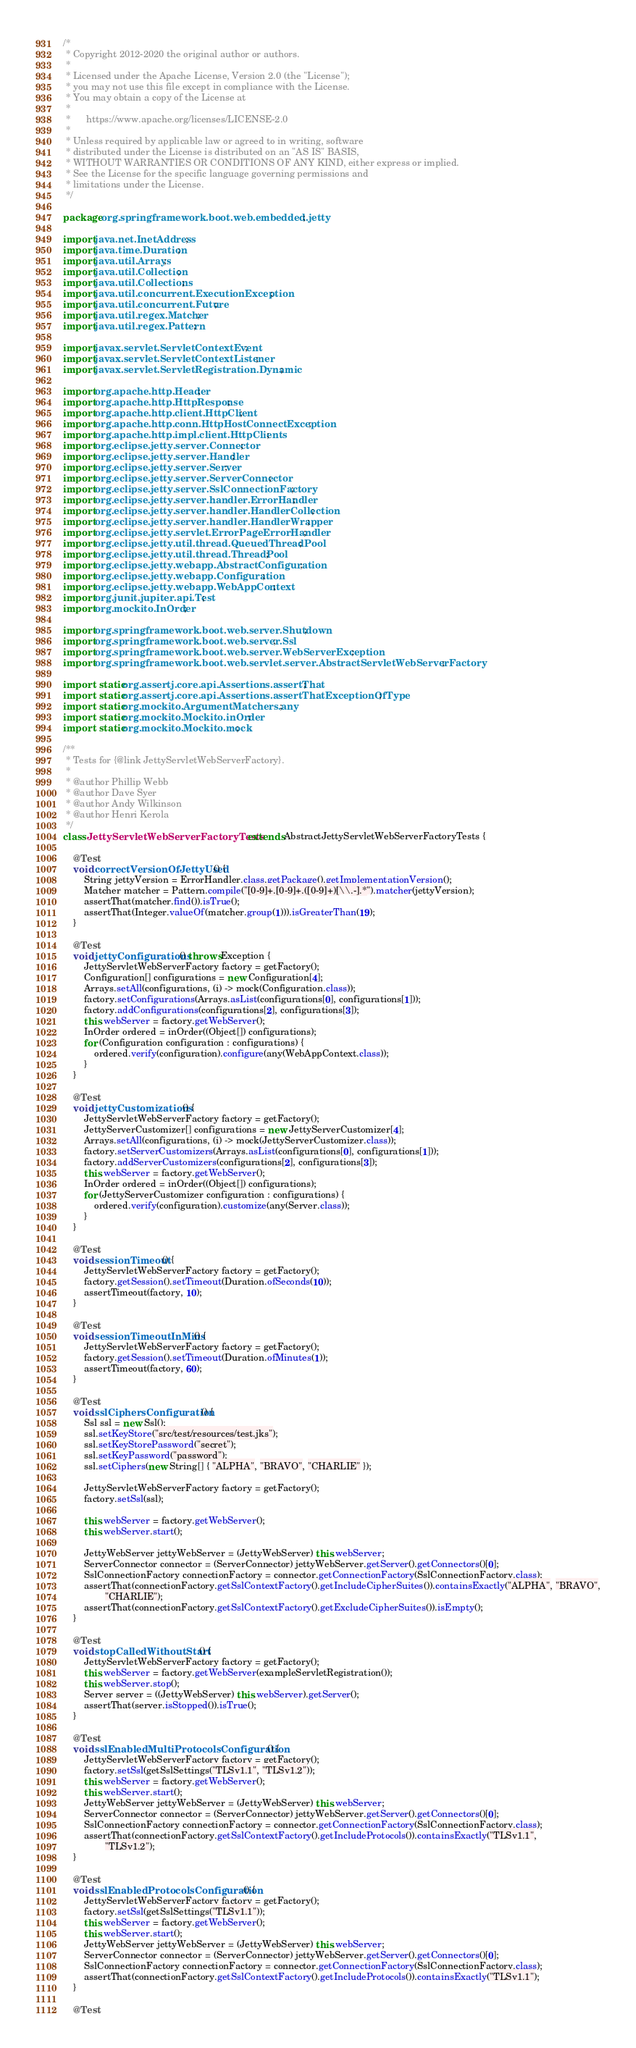<code> <loc_0><loc_0><loc_500><loc_500><_Java_>/*
 * Copyright 2012-2020 the original author or authors.
 *
 * Licensed under the Apache License, Version 2.0 (the "License");
 * you may not use this file except in compliance with the License.
 * You may obtain a copy of the License at
 *
 *      https://www.apache.org/licenses/LICENSE-2.0
 *
 * Unless required by applicable law or agreed to in writing, software
 * distributed under the License is distributed on an "AS IS" BASIS,
 * WITHOUT WARRANTIES OR CONDITIONS OF ANY KIND, either express or implied.
 * See the License for the specific language governing permissions and
 * limitations under the License.
 */

package org.springframework.boot.web.embedded.jetty;

import java.net.InetAddress;
import java.time.Duration;
import java.util.Arrays;
import java.util.Collection;
import java.util.Collections;
import java.util.concurrent.ExecutionException;
import java.util.concurrent.Future;
import java.util.regex.Matcher;
import java.util.regex.Pattern;

import javax.servlet.ServletContextEvent;
import javax.servlet.ServletContextListener;
import javax.servlet.ServletRegistration.Dynamic;

import org.apache.http.Header;
import org.apache.http.HttpResponse;
import org.apache.http.client.HttpClient;
import org.apache.http.conn.HttpHostConnectException;
import org.apache.http.impl.client.HttpClients;
import org.eclipse.jetty.server.Connector;
import org.eclipse.jetty.server.Handler;
import org.eclipse.jetty.server.Server;
import org.eclipse.jetty.server.ServerConnector;
import org.eclipse.jetty.server.SslConnectionFactory;
import org.eclipse.jetty.server.handler.ErrorHandler;
import org.eclipse.jetty.server.handler.HandlerCollection;
import org.eclipse.jetty.server.handler.HandlerWrapper;
import org.eclipse.jetty.servlet.ErrorPageErrorHandler;
import org.eclipse.jetty.util.thread.QueuedThreadPool;
import org.eclipse.jetty.util.thread.ThreadPool;
import org.eclipse.jetty.webapp.AbstractConfiguration;
import org.eclipse.jetty.webapp.Configuration;
import org.eclipse.jetty.webapp.WebAppContext;
import org.junit.jupiter.api.Test;
import org.mockito.InOrder;

import org.springframework.boot.web.server.Shutdown;
import org.springframework.boot.web.server.Ssl;
import org.springframework.boot.web.server.WebServerException;
import org.springframework.boot.web.servlet.server.AbstractServletWebServerFactory;

import static org.assertj.core.api.Assertions.assertThat;
import static org.assertj.core.api.Assertions.assertThatExceptionOfType;
import static org.mockito.ArgumentMatchers.any;
import static org.mockito.Mockito.inOrder;
import static org.mockito.Mockito.mock;

/**
 * Tests for {@link JettyServletWebServerFactory}.
 *
 * @author Phillip Webb
 * @author Dave Syer
 * @author Andy Wilkinson
 * @author Henri Kerola
 */
class JettyServletWebServerFactoryTests extends AbstractJettyServletWebServerFactoryTests {

	@Test
	void correctVersionOfJettyUsed() {
		String jettyVersion = ErrorHandler.class.getPackage().getImplementationVersion();
		Matcher matcher = Pattern.compile("[0-9]+.[0-9]+.([0-9]+)[\\.-].*").matcher(jettyVersion);
		assertThat(matcher.find()).isTrue();
		assertThat(Integer.valueOf(matcher.group(1))).isGreaterThan(19);
	}

	@Test
	void jettyConfigurations() throws Exception {
		JettyServletWebServerFactory factory = getFactory();
		Configuration[] configurations = new Configuration[4];
		Arrays.setAll(configurations, (i) -> mock(Configuration.class));
		factory.setConfigurations(Arrays.asList(configurations[0], configurations[1]));
		factory.addConfigurations(configurations[2], configurations[3]);
		this.webServer = factory.getWebServer();
		InOrder ordered = inOrder((Object[]) configurations);
		for (Configuration configuration : configurations) {
			ordered.verify(configuration).configure(any(WebAppContext.class));
		}
	}

	@Test
	void jettyCustomizations() {
		JettyServletWebServerFactory factory = getFactory();
		JettyServerCustomizer[] configurations = new JettyServerCustomizer[4];
		Arrays.setAll(configurations, (i) -> mock(JettyServerCustomizer.class));
		factory.setServerCustomizers(Arrays.asList(configurations[0], configurations[1]));
		factory.addServerCustomizers(configurations[2], configurations[3]);
		this.webServer = factory.getWebServer();
		InOrder ordered = inOrder((Object[]) configurations);
		for (JettyServerCustomizer configuration : configurations) {
			ordered.verify(configuration).customize(any(Server.class));
		}
	}

	@Test
	void sessionTimeout() {
		JettyServletWebServerFactory factory = getFactory();
		factory.getSession().setTimeout(Duration.ofSeconds(10));
		assertTimeout(factory, 10);
	}

	@Test
	void sessionTimeoutInMins() {
		JettyServletWebServerFactory factory = getFactory();
		factory.getSession().setTimeout(Duration.ofMinutes(1));
		assertTimeout(factory, 60);
	}

	@Test
	void sslCiphersConfiguration() {
		Ssl ssl = new Ssl();
		ssl.setKeyStore("src/test/resources/test.jks");
		ssl.setKeyStorePassword("secret");
		ssl.setKeyPassword("password");
		ssl.setCiphers(new String[] { "ALPHA", "BRAVO", "CHARLIE" });

		JettyServletWebServerFactory factory = getFactory();
		factory.setSsl(ssl);

		this.webServer = factory.getWebServer();
		this.webServer.start();

		JettyWebServer jettyWebServer = (JettyWebServer) this.webServer;
		ServerConnector connector = (ServerConnector) jettyWebServer.getServer().getConnectors()[0];
		SslConnectionFactory connectionFactory = connector.getConnectionFactory(SslConnectionFactory.class);
		assertThat(connectionFactory.getSslContextFactory().getIncludeCipherSuites()).containsExactly("ALPHA", "BRAVO",
				"CHARLIE");
		assertThat(connectionFactory.getSslContextFactory().getExcludeCipherSuites()).isEmpty();
	}

	@Test
	void stopCalledWithoutStart() {
		JettyServletWebServerFactory factory = getFactory();
		this.webServer = factory.getWebServer(exampleServletRegistration());
		this.webServer.stop();
		Server server = ((JettyWebServer) this.webServer).getServer();
		assertThat(server.isStopped()).isTrue();
	}

	@Test
	void sslEnabledMultiProtocolsConfiguration() {
		JettyServletWebServerFactory factory = getFactory();
		factory.setSsl(getSslSettings("TLSv1.1", "TLSv1.2"));
		this.webServer = factory.getWebServer();
		this.webServer.start();
		JettyWebServer jettyWebServer = (JettyWebServer) this.webServer;
		ServerConnector connector = (ServerConnector) jettyWebServer.getServer().getConnectors()[0];
		SslConnectionFactory connectionFactory = connector.getConnectionFactory(SslConnectionFactory.class);
		assertThat(connectionFactory.getSslContextFactory().getIncludeProtocols()).containsExactly("TLSv1.1",
				"TLSv1.2");
	}

	@Test
	void sslEnabledProtocolsConfiguration() {
		JettyServletWebServerFactory factory = getFactory();
		factory.setSsl(getSslSettings("TLSv1.1"));
		this.webServer = factory.getWebServer();
		this.webServer.start();
		JettyWebServer jettyWebServer = (JettyWebServer) this.webServer;
		ServerConnector connector = (ServerConnector) jettyWebServer.getServer().getConnectors()[0];
		SslConnectionFactory connectionFactory = connector.getConnectionFactory(SslConnectionFactory.class);
		assertThat(connectionFactory.getSslContextFactory().getIncludeProtocols()).containsExactly("TLSv1.1");
	}

	@Test</code> 